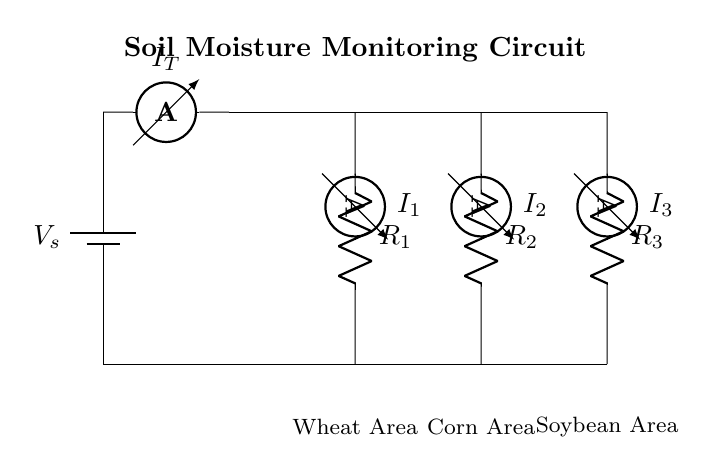What is the total current in the circuit? The total current, denoted as I_T, is represented by the ammeter in the main path of the circuit. It flows from the power source through the ammeter.
Answer: I_T What components are present in this circuit? The circuit consists of a battery, ammeters, and resistors, labeled as R1, R2, and R3. The ammeters measure the current in each branch, while the resistors represent the soil moisture levels in different crop areas.
Answer: Battery, ammeters, resistors Which crop area is associated with resistor R1? Resistor R1 is located in the branch connecting to the wheat crop area, as indicated by the label in the circuit diagram directly below R1.
Answer: Wheat Area How does the current divide in this circuit? The current divides based on the resistance values of R1, R2, and R3, following the current divider rule. Each branch receives a portion of the total current I_T inversely proportional to its resistance.
Answer: By resistance values What does the presence of ammeters in the branches indicate? Ammeters indicate the current flowing through each respective branch. Their readings will help in assessing the moisture levels in the various crop areas by showing the current derived from the total current.
Answer: Current measurement What can be inferred if the current through R3 is higher than through R1? If the current through R3 is higher, it suggests that the resistance of R3 is lower compared to R1, indicating potentially better moisture conditions in the soybean area than in the wheat area.
Answer: Lower resistance in R3 